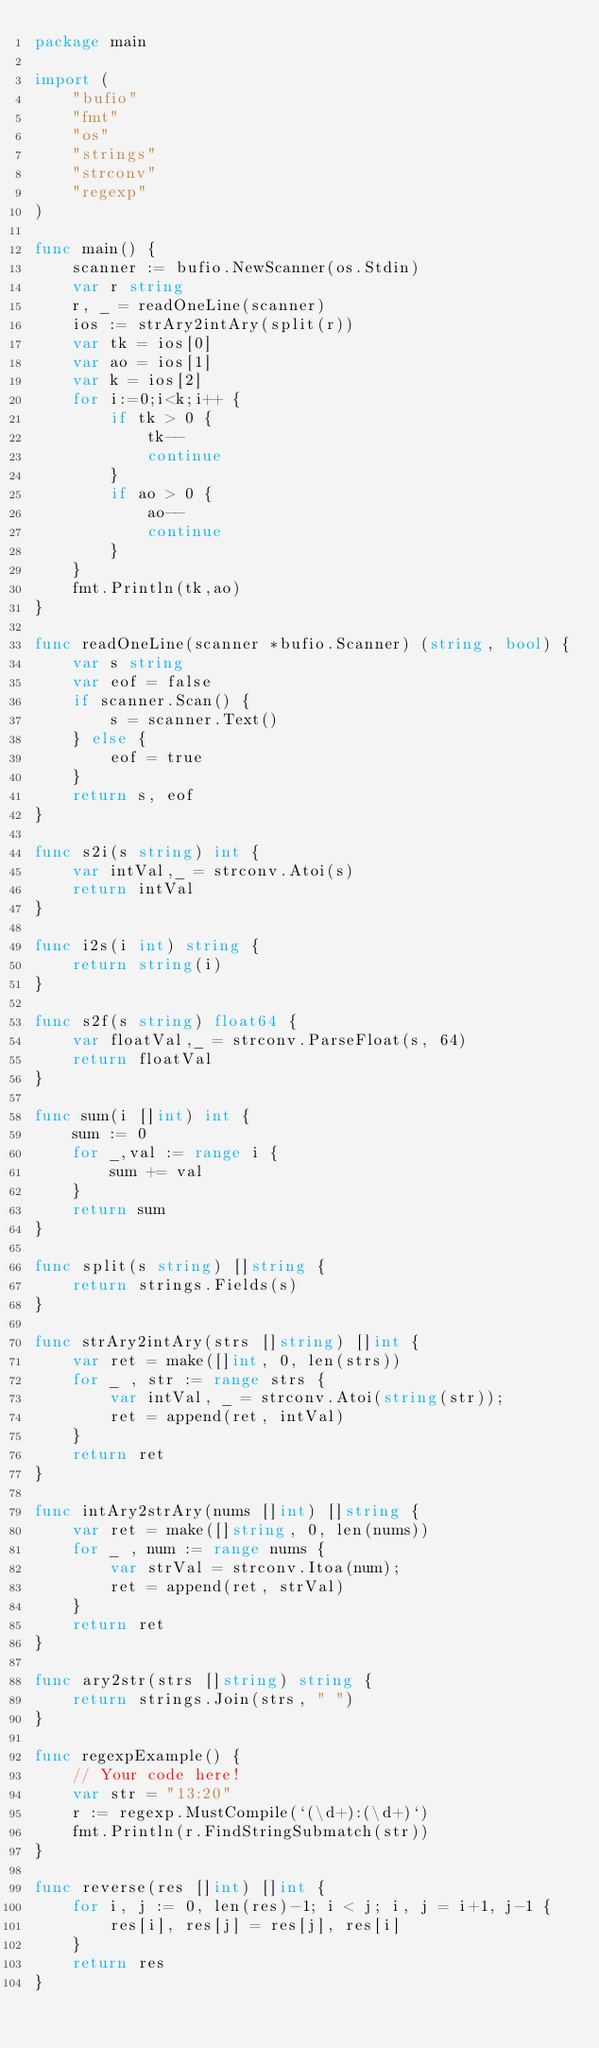Convert code to text. <code><loc_0><loc_0><loc_500><loc_500><_Go_>package main

import (
    "bufio"
    "fmt"
    "os"
    "strings"
    "strconv"
    "regexp"
)

func main() {
    scanner := bufio.NewScanner(os.Stdin)
    var r string
    r, _ = readOneLine(scanner)
    ios := strAry2intAry(split(r))
    var tk = ios[0]
    var ao = ios[1]
    var k = ios[2]
    for i:=0;i<k;i++ {
        if tk > 0 {
            tk--
            continue
        }
        if ao > 0 {
            ao--
            continue
        }
    }
    fmt.Println(tk,ao)
}

func readOneLine(scanner *bufio.Scanner) (string, bool) {
    var s string
    var eof = false
    if scanner.Scan() {
        s = scanner.Text()
    } else {
        eof = true
    }
    return s, eof
}

func s2i(s string) int {
    var intVal,_ = strconv.Atoi(s)
    return intVal
}

func i2s(i int) string {
    return string(i)
}

func s2f(s string) float64 {
    var floatVal,_ = strconv.ParseFloat(s, 64)
    return floatVal
}

func sum(i []int) int {
    sum := 0
    for _,val := range i {
        sum += val
    }
    return sum
}

func split(s string) []string {
    return strings.Fields(s)
}

func strAry2intAry(strs []string) []int {
    var ret = make([]int, 0, len(strs))
    for _ , str := range strs {
        var intVal, _ = strconv.Atoi(string(str));
        ret = append(ret, intVal)
    }
    return ret
}

func intAry2strAry(nums []int) []string {
    var ret = make([]string, 0, len(nums))
    for _ , num := range nums {
        var strVal = strconv.Itoa(num);
        ret = append(ret, strVal)
    }
    return ret
}

func ary2str(strs []string) string {
    return strings.Join(strs, " ")
}

func regexpExample() {
    // Your code here!
    var str = "13:20"
    r := regexp.MustCompile(`(\d+):(\d+)`)
    fmt.Println(r.FindStringSubmatch(str))
}

func reverse(res []int) []int {
    for i, j := 0, len(res)-1; i < j; i, j = i+1, j-1 {
        res[i], res[j] = res[j], res[i]
    }
    return res
}
</code> 